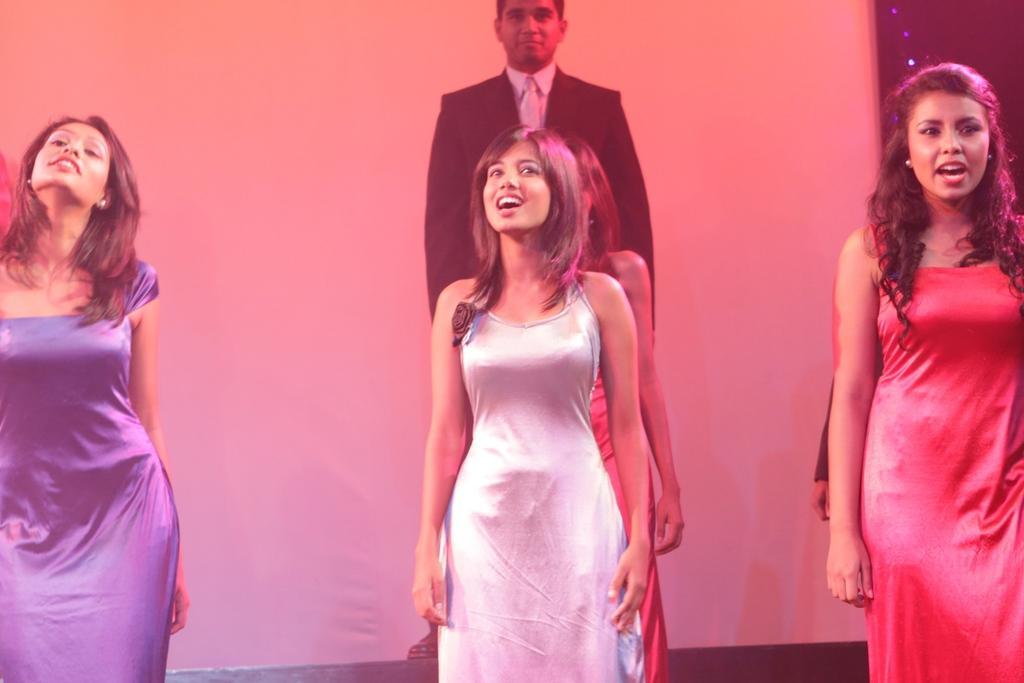How would you summarize this image in a sentence or two? In this image there are people standing, in the background there is white curtain. 